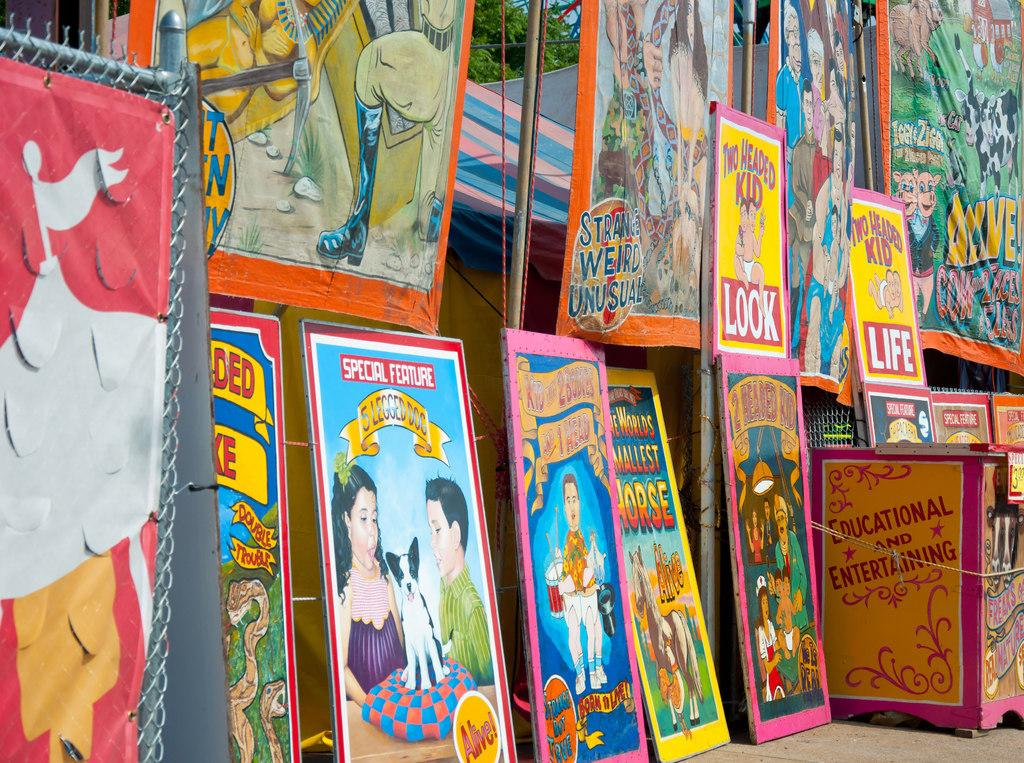<image>
Present a compact description of the photo's key features. magazines standing up on  a table with one that says 'special feature' at the top 